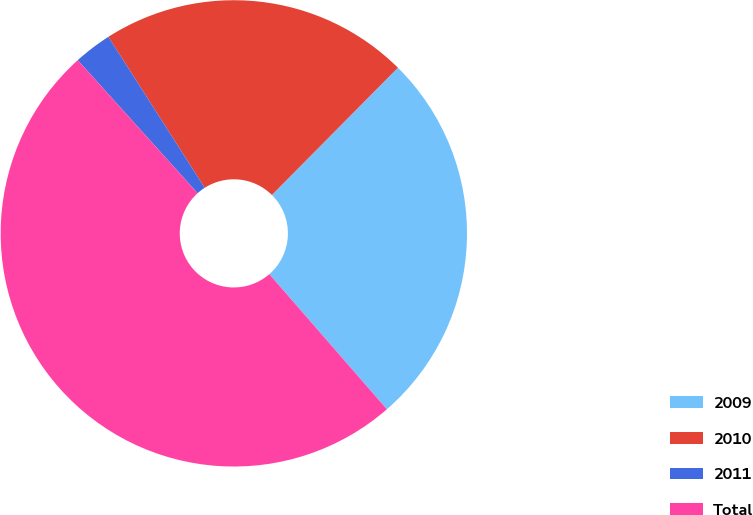<chart> <loc_0><loc_0><loc_500><loc_500><pie_chart><fcel>2009<fcel>2010<fcel>2011<fcel>Total<nl><fcel>26.18%<fcel>21.47%<fcel>2.63%<fcel>49.73%<nl></chart> 